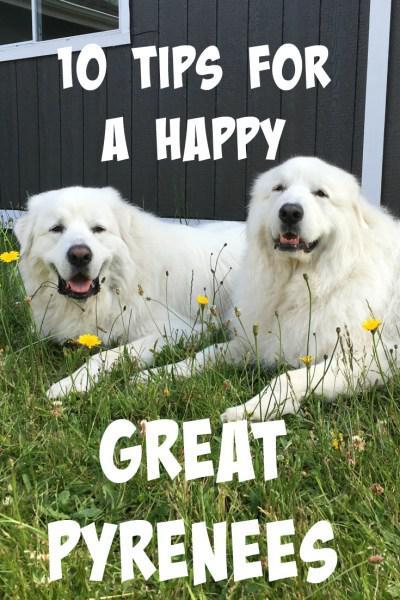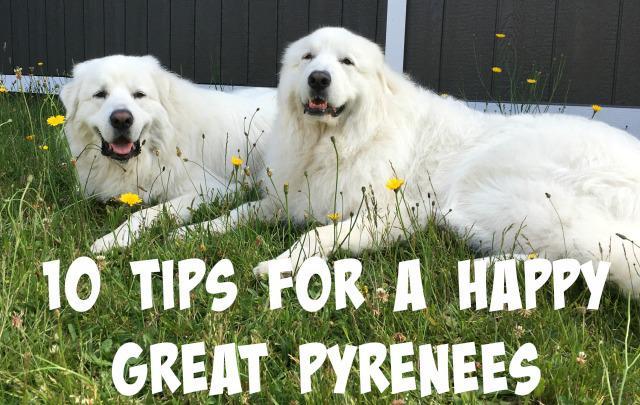The first image is the image on the left, the second image is the image on the right. Considering the images on both sides, is "There is a total of four dogs." valid? Answer yes or no. Yes. 